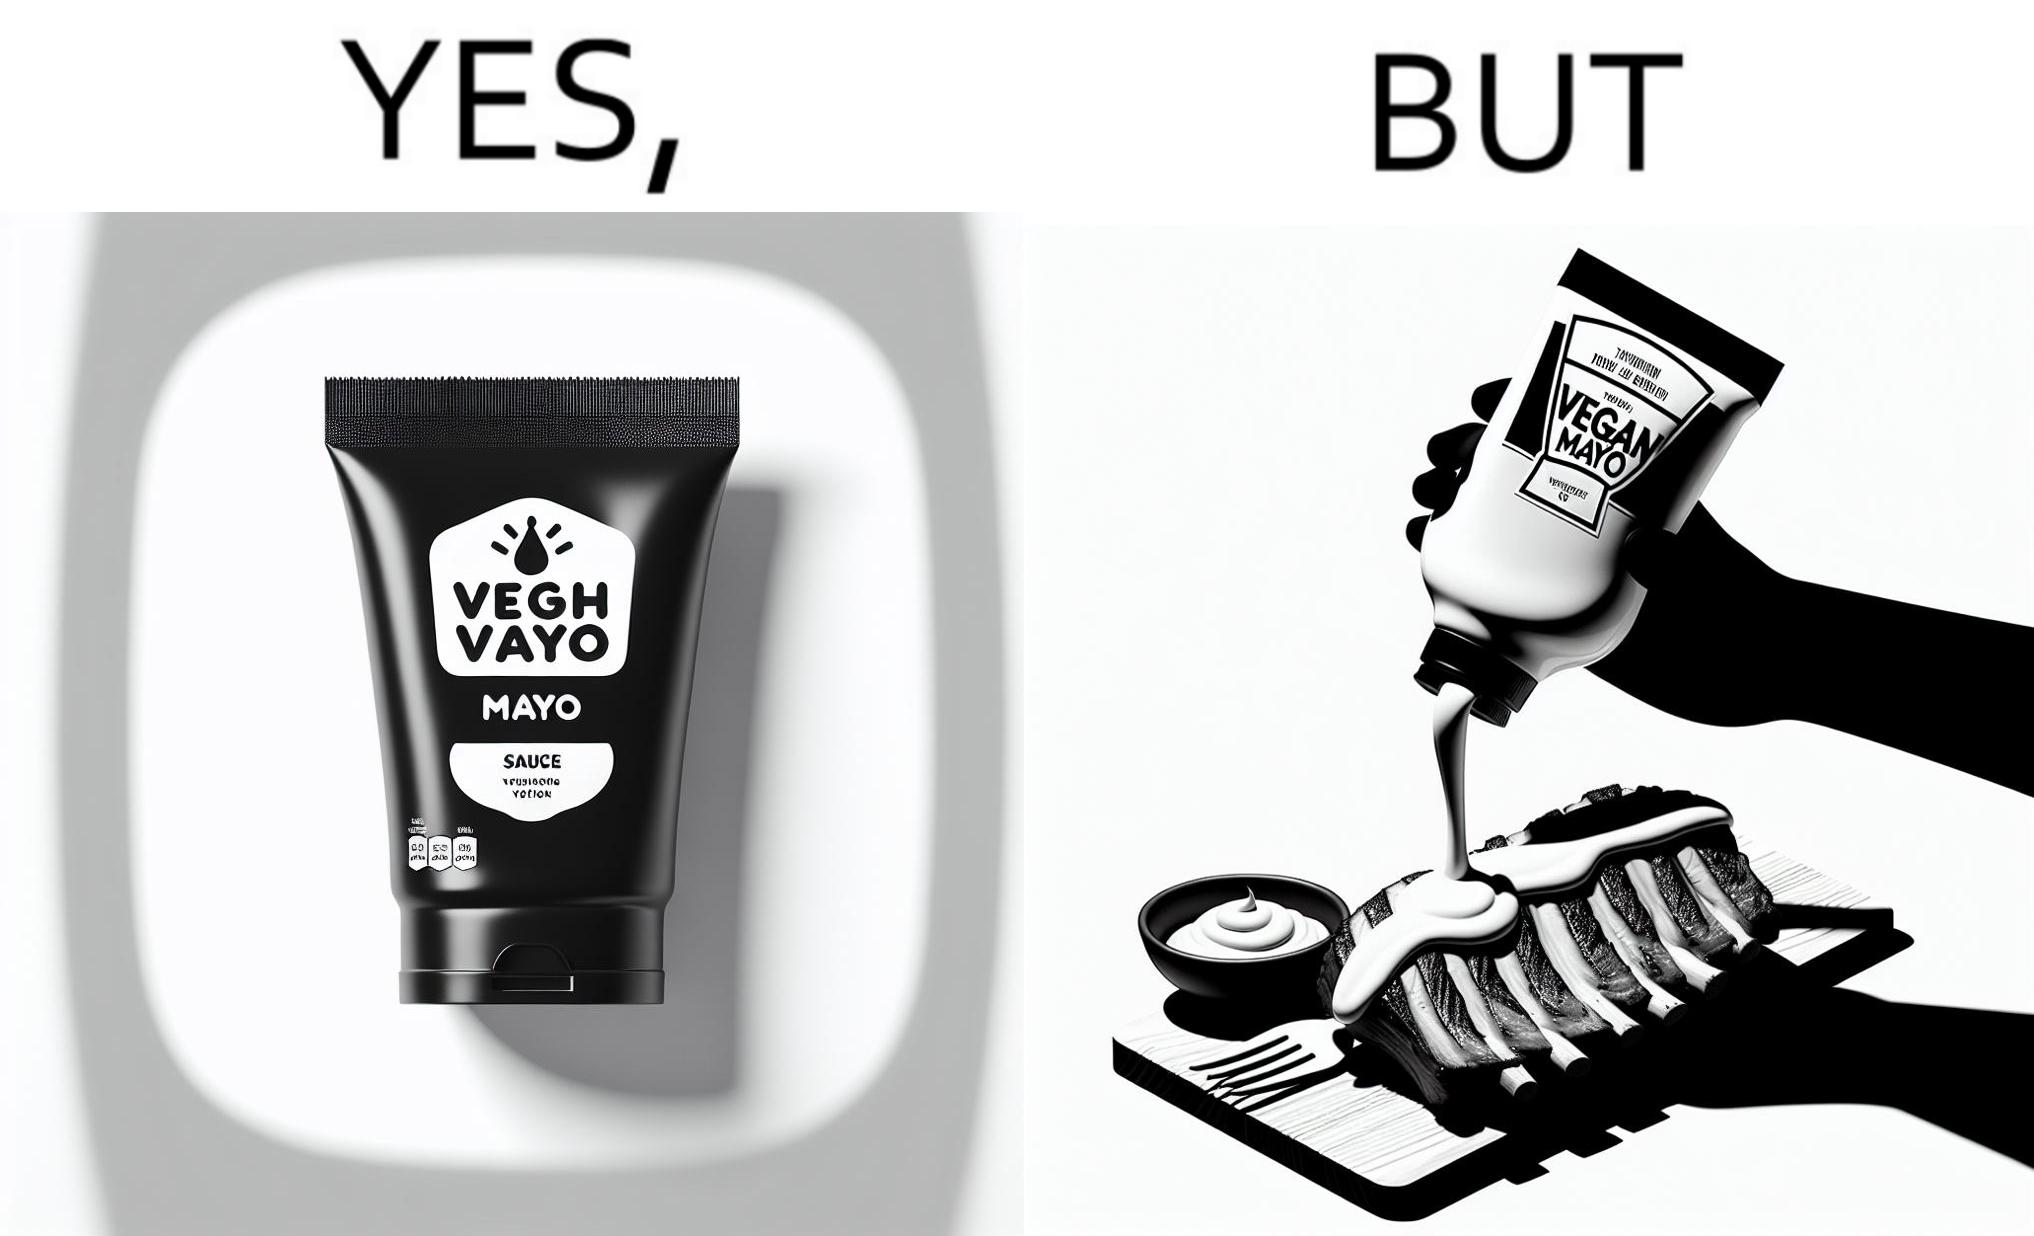What is shown in the left half versus the right half of this image? In the left part of the image: a vegan mayo sauce packet In the right part of the image: pouring vegan mayo sauce from a packet on a rib steak 